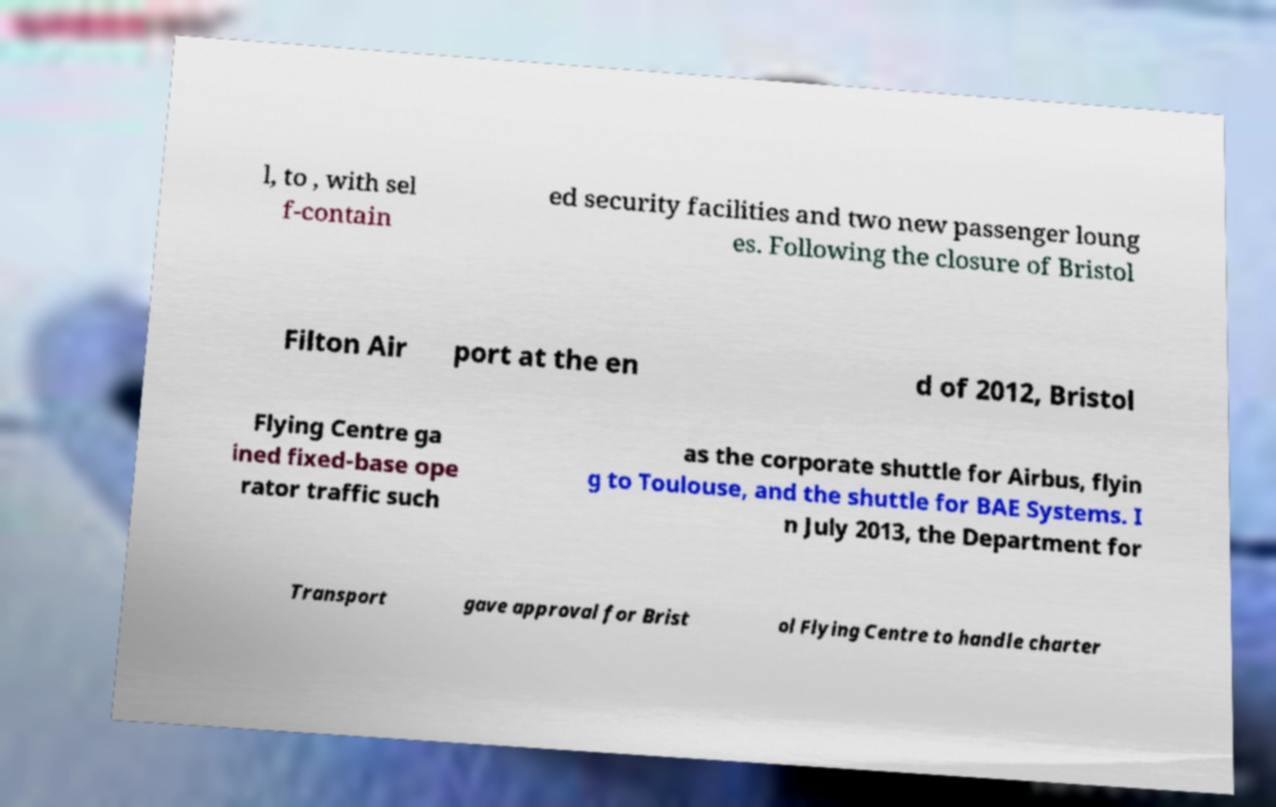I need the written content from this picture converted into text. Can you do that? l, to , with sel f-contain ed security facilities and two new passenger loung es. Following the closure of Bristol Filton Air port at the en d of 2012, Bristol Flying Centre ga ined fixed-base ope rator traffic such as the corporate shuttle for Airbus, flyin g to Toulouse, and the shuttle for BAE Systems. I n July 2013, the Department for Transport gave approval for Brist ol Flying Centre to handle charter 